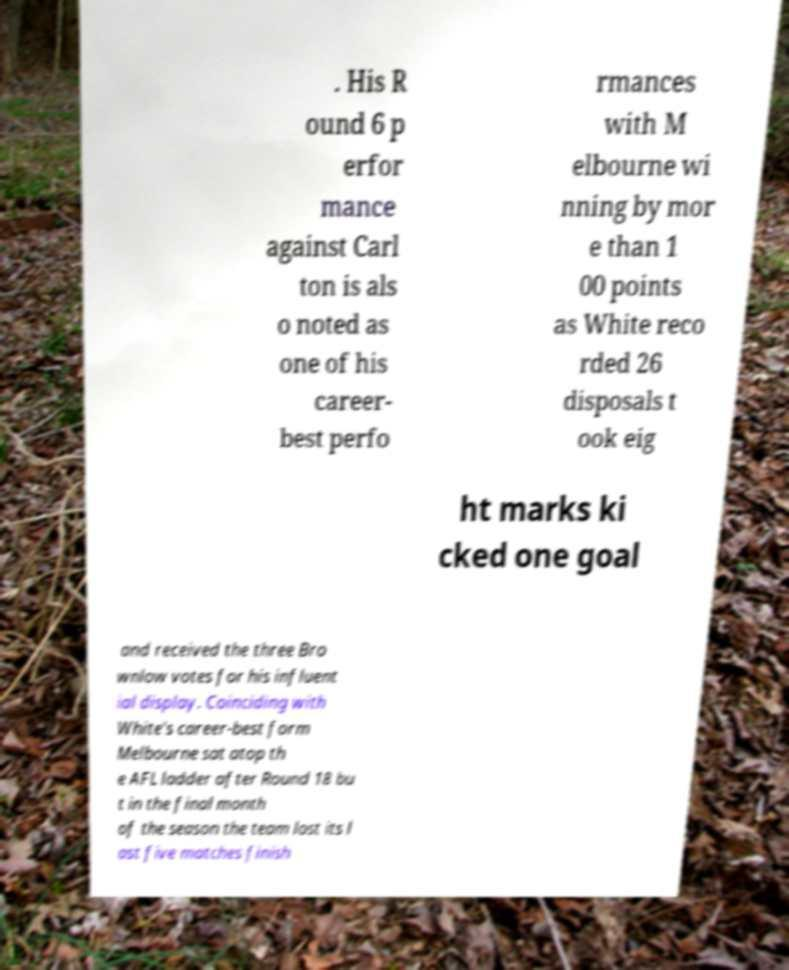Could you extract and type out the text from this image? . His R ound 6 p erfor mance against Carl ton is als o noted as one of his career- best perfo rmances with M elbourne wi nning by mor e than 1 00 points as White reco rded 26 disposals t ook eig ht marks ki cked one goal and received the three Bro wnlow votes for his influent ial display. Coinciding with White's career-best form Melbourne sat atop th e AFL ladder after Round 18 bu t in the final month of the season the team lost its l ast five matches finish 